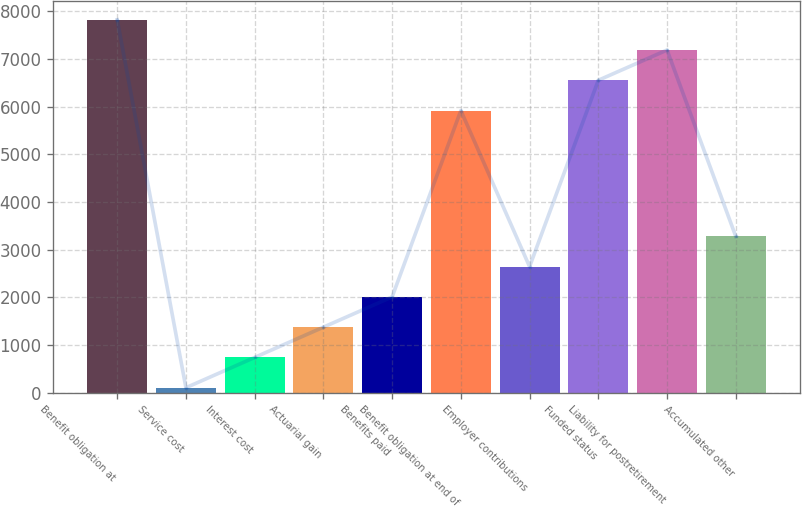<chart> <loc_0><loc_0><loc_500><loc_500><bar_chart><fcel>Benefit obligation at<fcel>Service cost<fcel>Interest cost<fcel>Actuarial gain<fcel>Benefits paid<fcel>Benefit obligation at end of<fcel>Employer contributions<fcel>Funded status<fcel>Liability for postretirement<fcel>Accumulated other<nl><fcel>7824.9<fcel>101<fcel>736.3<fcel>1371.6<fcel>2006.9<fcel>5919<fcel>2642.2<fcel>6554.3<fcel>7189.6<fcel>3277.5<nl></chart> 